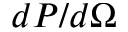<formula> <loc_0><loc_0><loc_500><loc_500>d P / d \Omega</formula> 